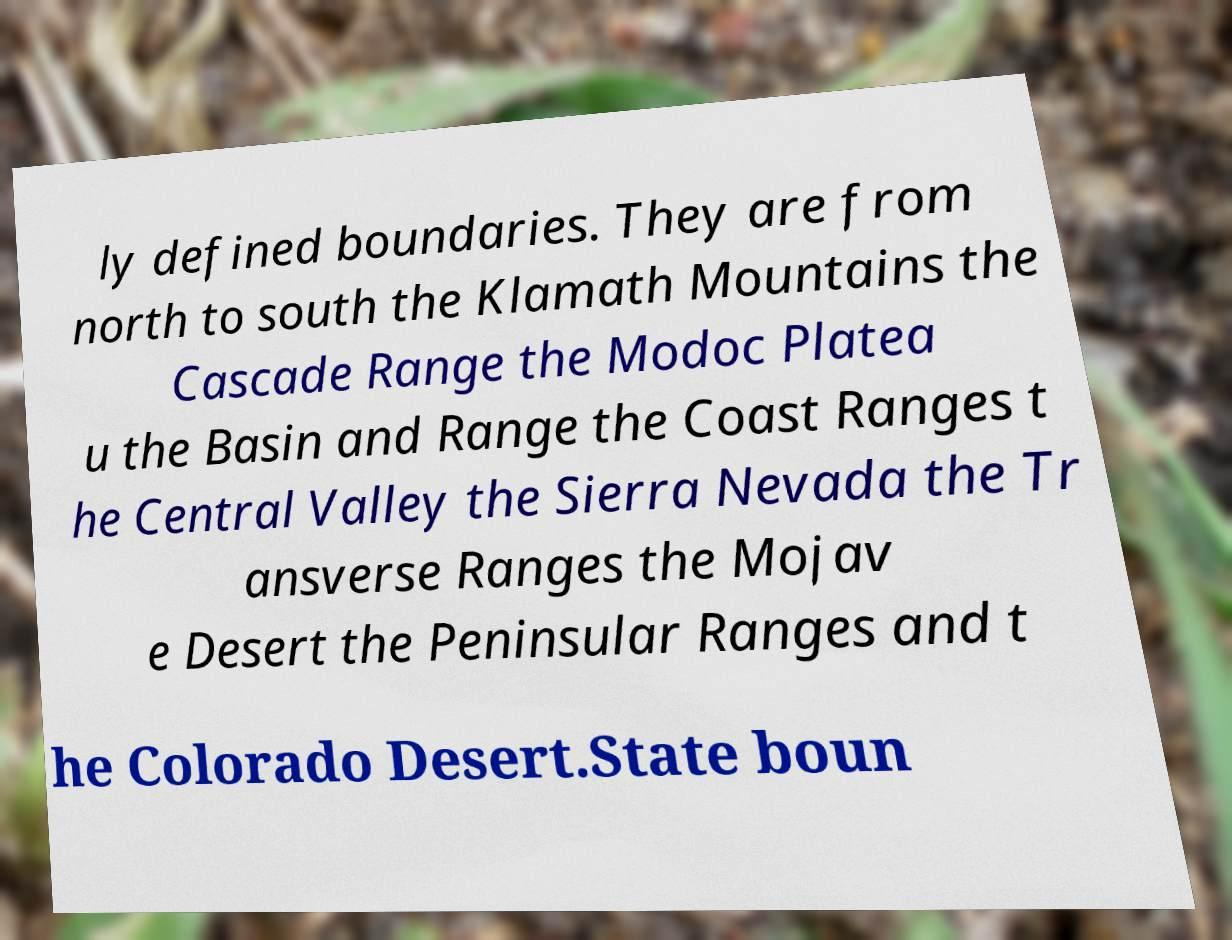Can you accurately transcribe the text from the provided image for me? ly defined boundaries. They are from north to south the Klamath Mountains the Cascade Range the Modoc Platea u the Basin and Range the Coast Ranges t he Central Valley the Sierra Nevada the Tr ansverse Ranges the Mojav e Desert the Peninsular Ranges and t he Colorado Desert.State boun 